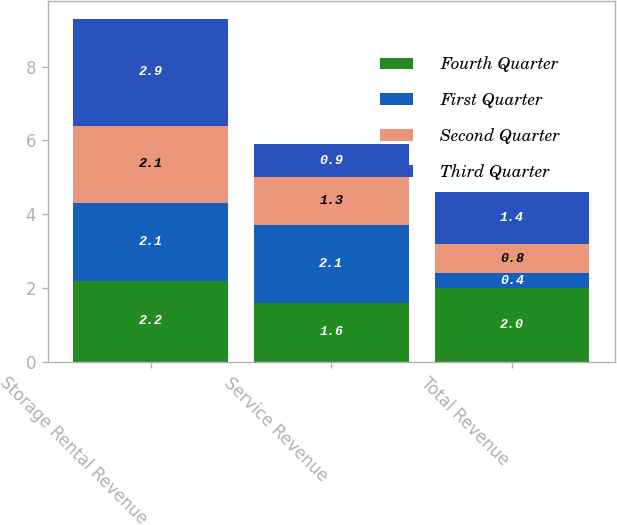<chart> <loc_0><loc_0><loc_500><loc_500><stacked_bar_chart><ecel><fcel>Storage Rental Revenue<fcel>Service Revenue<fcel>Total Revenue<nl><fcel>Fourth Quarter<fcel>2.2<fcel>1.6<fcel>2<nl><fcel>First Quarter<fcel>2.1<fcel>2.1<fcel>0.4<nl><fcel>Second Quarter<fcel>2.1<fcel>1.3<fcel>0.8<nl><fcel>Third Quarter<fcel>2.9<fcel>0.9<fcel>1.4<nl></chart> 